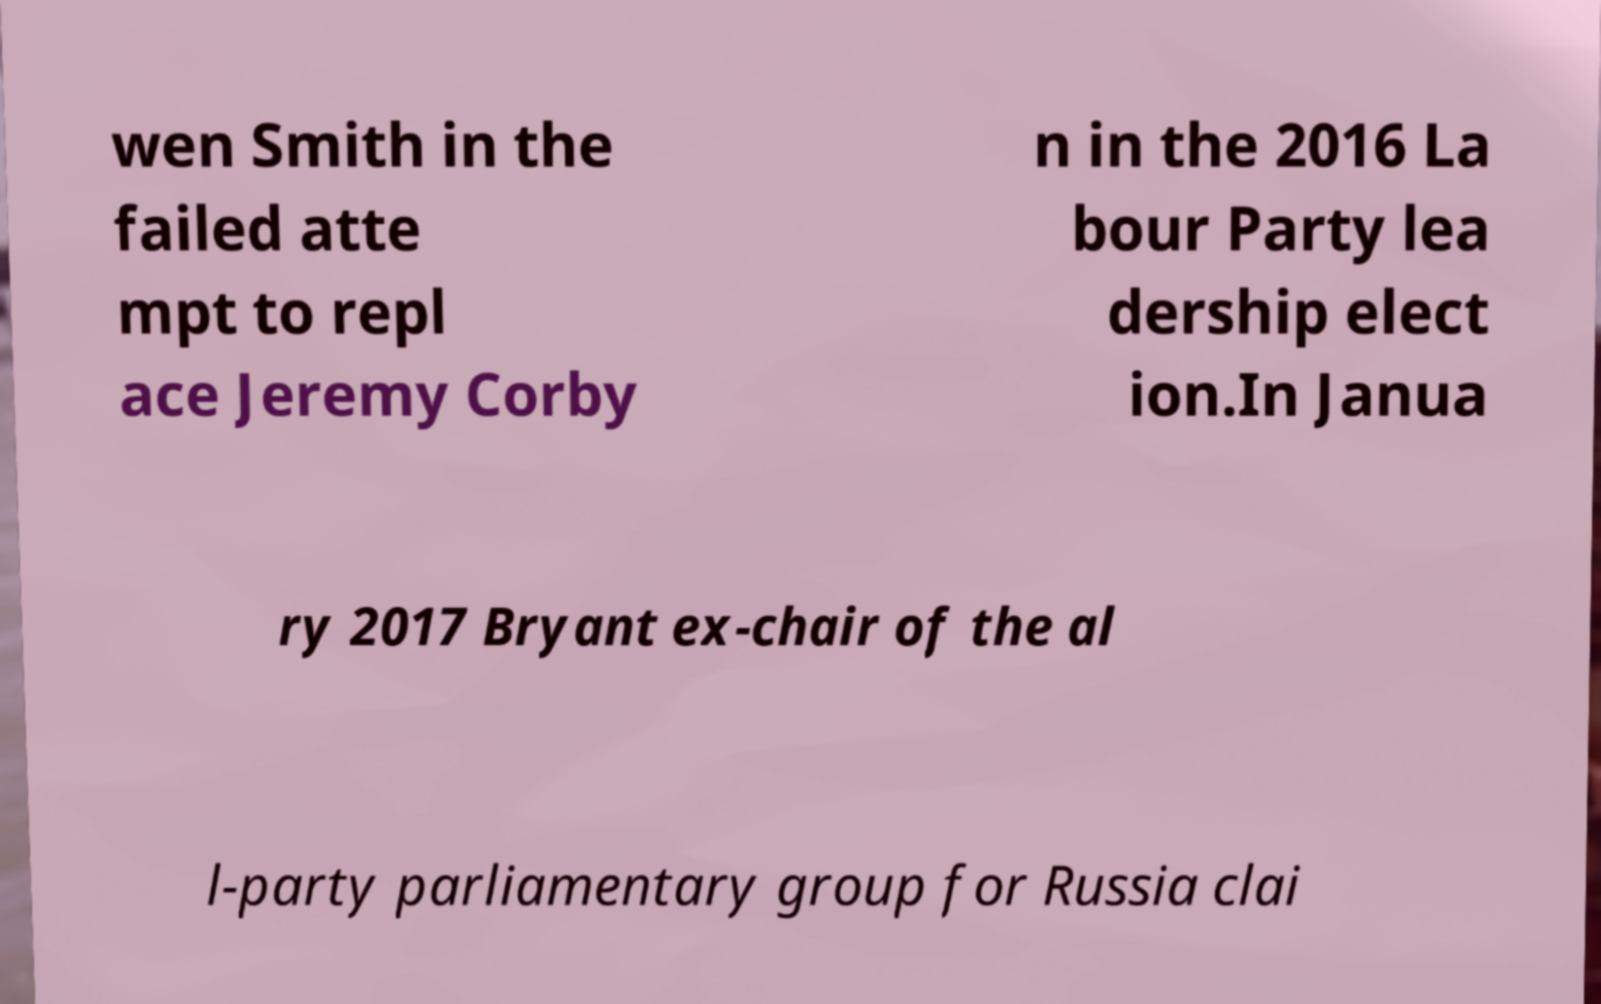Please identify and transcribe the text found in this image. wen Smith in the failed atte mpt to repl ace Jeremy Corby n in the 2016 La bour Party lea dership elect ion.In Janua ry 2017 Bryant ex-chair of the al l-party parliamentary group for Russia clai 